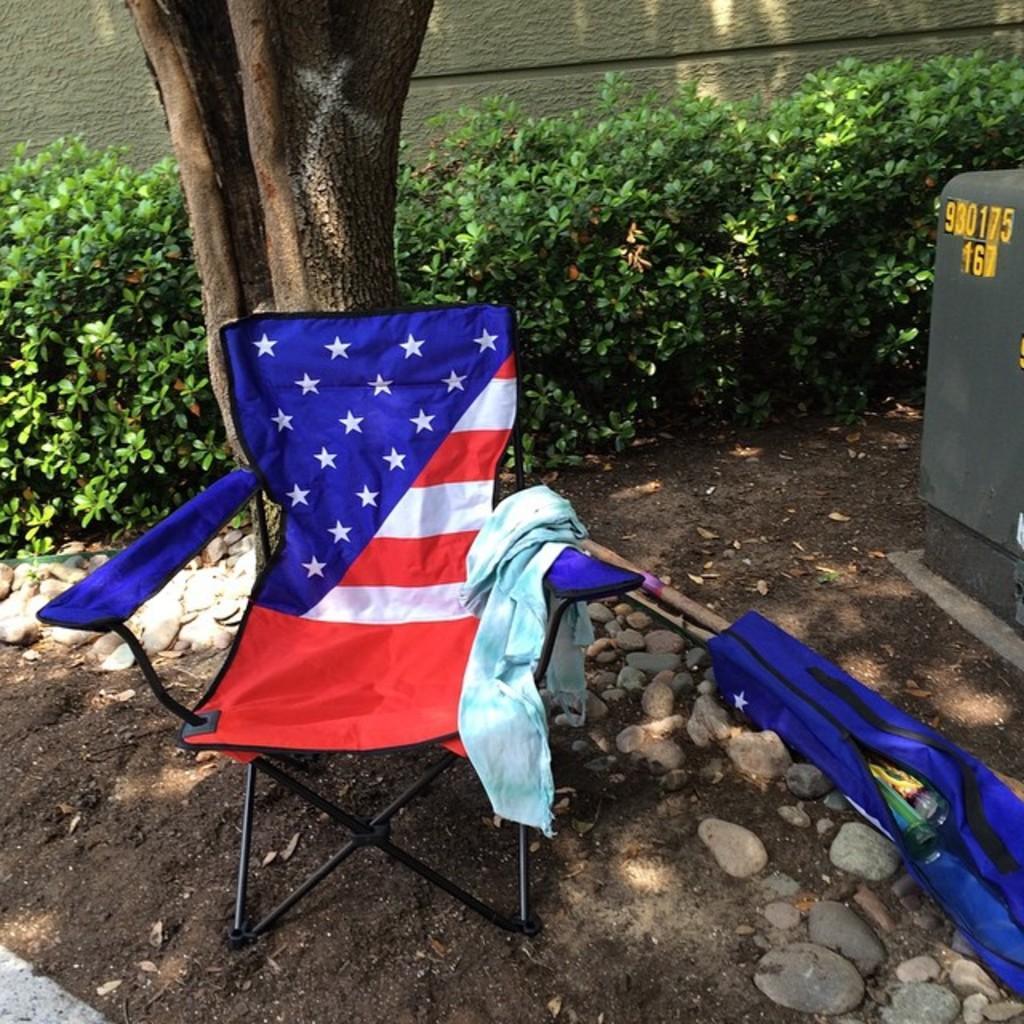Please provide a concise description of this image. In the foreground I can see a chair, cloth, box, plants, tree trunk and a wall. This image is taken may be in a garden. 